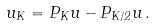<formula> <loc_0><loc_0><loc_500><loc_500>u _ { K } = P _ { K } u - P _ { K / 2 } u \, .</formula> 